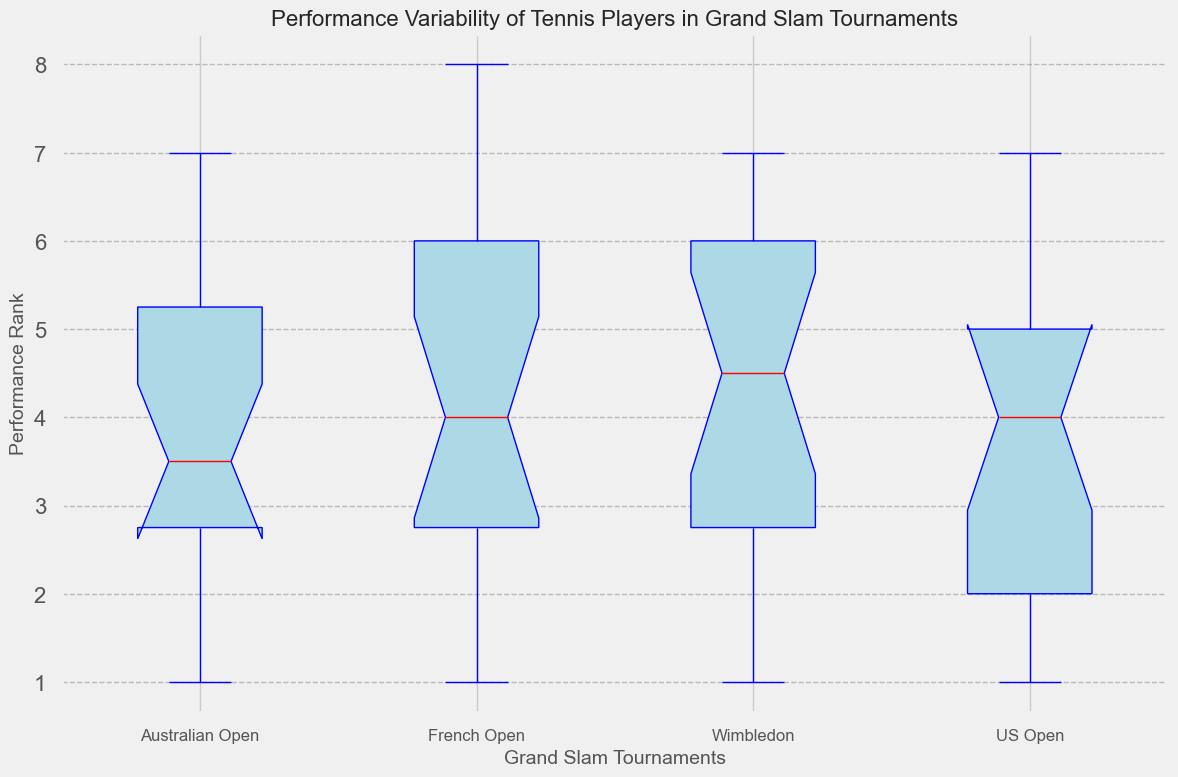What is the median performance rank of players in Wimbledon? The box plot displays the median as a red line within the box. By observing the box for Wimbledon, we see that the red line is positioned at a value of 5.
Answer: 5 Which tournament shows the greatest variability in performance ranks? Variability is indicated by the length of the box and whiskers. The tournament with the longest box and whiskers represents the highest variability. By comparing, the French Open has the largest spread from minimum to maximum values.
Answer: French Open Which tournament has the lowest median performance rank? The median is shown as the red line in each box. By comparing the four red lines, the US Open's median line is the lowest (closest to 1).
Answer: US Open How many tournaments have a median performance rank of 4 or below? To determine this, we look at the position of the red median lines in each box plot. Both the French Open and the US Open have medians that are below or equal to 4.
Answer: 2 What is the interquartile range (IQR) for the US Open? The IQR is the range between the first quartile (Q1) and the third quartile (Q3), represented by the edges of the box. For the US Open, the lower edge is at 2, and the upper edge is at 5. Therefore, IQR = 5 - 2.
Answer: 3 Compare the median ranks of Australian Open and French Open. Which is higher? By looking at the red median lines, we see that the Australian Open’s median is at 3 and the French Open’s median is at 5. The French Open’s median is higher.
Answer: French Open Which tournament has the smallest interquartile range? The IQR is the width of the box. By comparing the box widths, the Australian Open's box is the narrowest, indicating the smallest IQR.
Answer: Australian Open Is the median performance for Wimbledon players higher than the French Open players? We compare the positions of the red median lines for Wimbledon and French Open. The Wimbledon median line is at 5, which is the same as the French Open's median line. Thus, they are equal.
Answer: Equal Which tournament shows outliers, and how are they represented visually? Outliers are represented by markers outside the whiskers. In the French Open box plot, there are points marked with "+" beyond the whiskers, indicating outliers.
Answer: French Open 